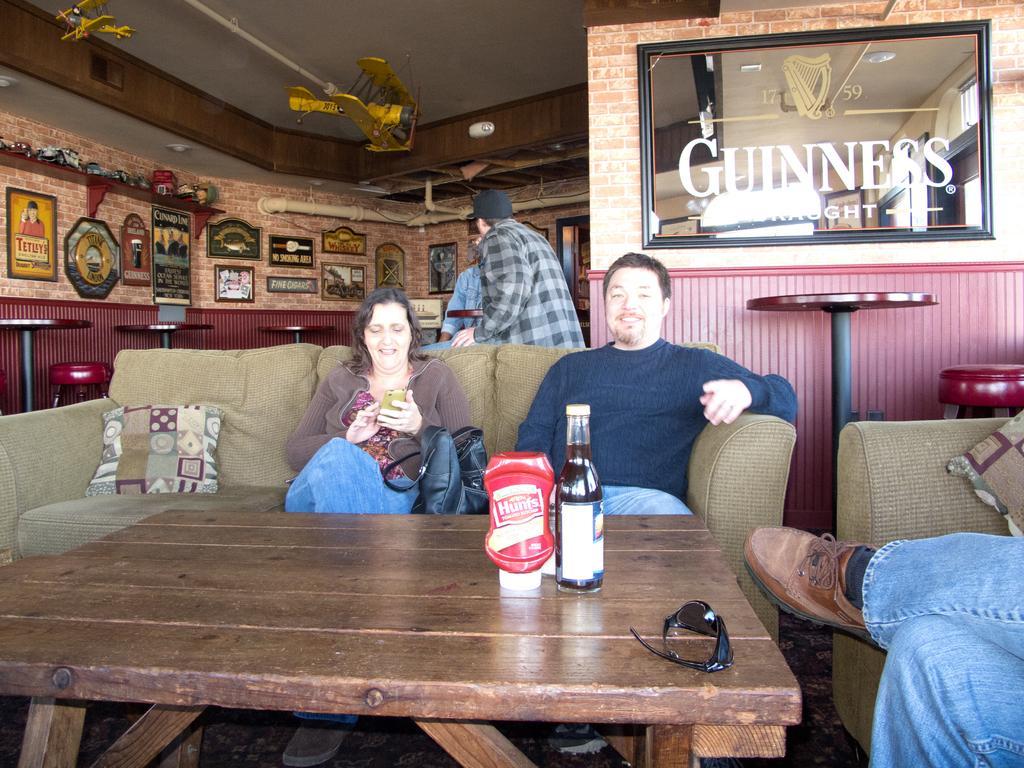In one or two sentences, can you explain what this image depicts? In this image I can see people were few of them are sitting on sofas and few are standing. I can also see few bottles and sunglasses on this table. In the background I can see few frames on this wall. 